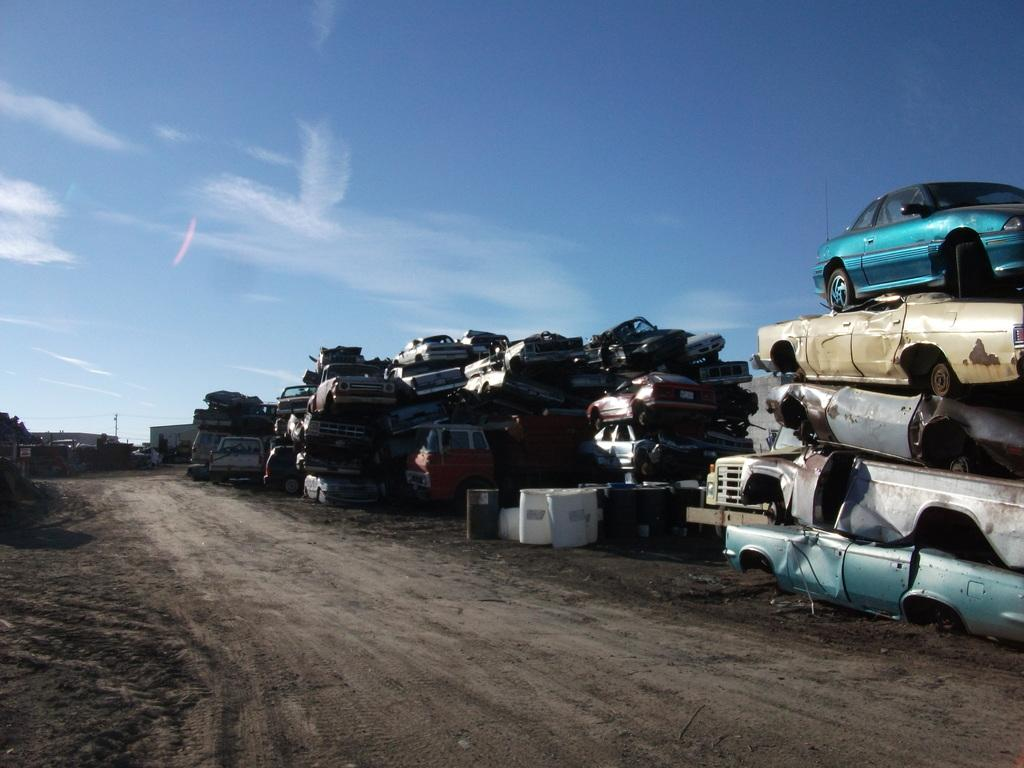What is the main feature of the image? There is a road in the image. What is happening on the road? There is a group of cars on the road. What can be seen at the top of the image? There are containers visible at the top of the image. What is visible in the background of the image? The sky is visible in the image. What type of sack is being used to act in the image? There is no sack or act present in the image. What suggestion is being made by the group of cars in the image? There is no suggestion being made by the group of cars in the image; they are simply driving on the road. 